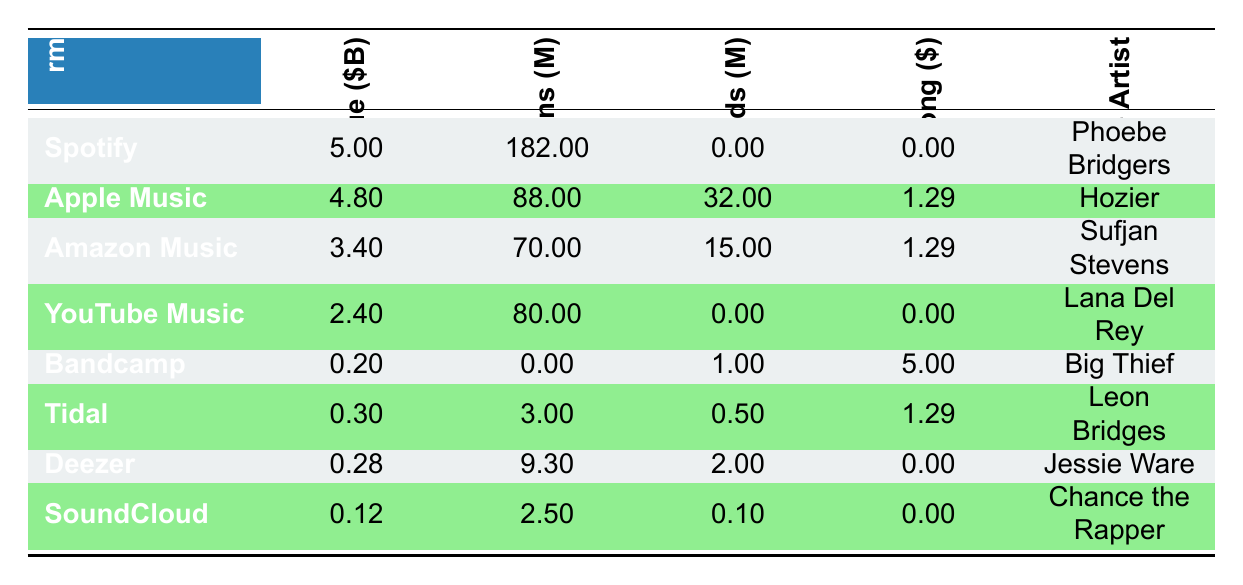What is the total revenue generated by all digital music platforms in 2022? To find the total revenue, we need to sum the revenue values of all platforms listed in the table. The revenues are: 5.00 + 4.80 + 3.40 + 2.40 + 0.20 + 0.30 + 0.28 + 0.12 = 16.60 billion dollars.
Answer: 16.60 billion dollars Which platform had the highest number of subscriptions? By examining the subscriptions column, we see that Spotify has 182 million subscriptions, which is the highest compared to other platforms.
Answer: Spotify Did Bandcamp generate any revenue from subscriptions? Bandcamp shows subscriptions listed as 0 million, indicating that it did not generate any revenue from subscriptions.
Answer: No What is the average price per song for Apple Music and Amazon Music combined? The average price per song for Apple Music is 1.29, and for Amazon Music, it is also 1.29. To find the average of these two values, we sum them (1.29 + 1.29) = 2.58 and then divide by 2, resulting in an average price of 1.29 dollars per song.
Answer: 1.29 dollars How many downloads did YouTube Music have compared to Bandcamp? YouTube Music had 0 downloads, while Bandcamp had 1 million downloads. Since 0 is less than 1 million, Bandcamp had more downloads than YouTube Music.
Answer: Bandcamp had more downloads What is the notable indie artist associated with the highest revenue platform? The platform with the highest revenue is Spotify, which is associated with the notable indie artist Phoebe Bridgers.
Answer: Phoebe Bridgers Is the average price per song for Tidal higher than the average price for Deezer? Tidal has an average price per song of 1.29, while Deezer has an average price of 0.00. Since 1.29 is greater than 0.00, the answer is yes.
Answer: Yes Which platform had the lowest revenue and what was that amount? Looking at the revenue column, the lowest revenue is for SoundCloud, at 0.12 billion dollars.
Answer: 0.12 billion dollars 